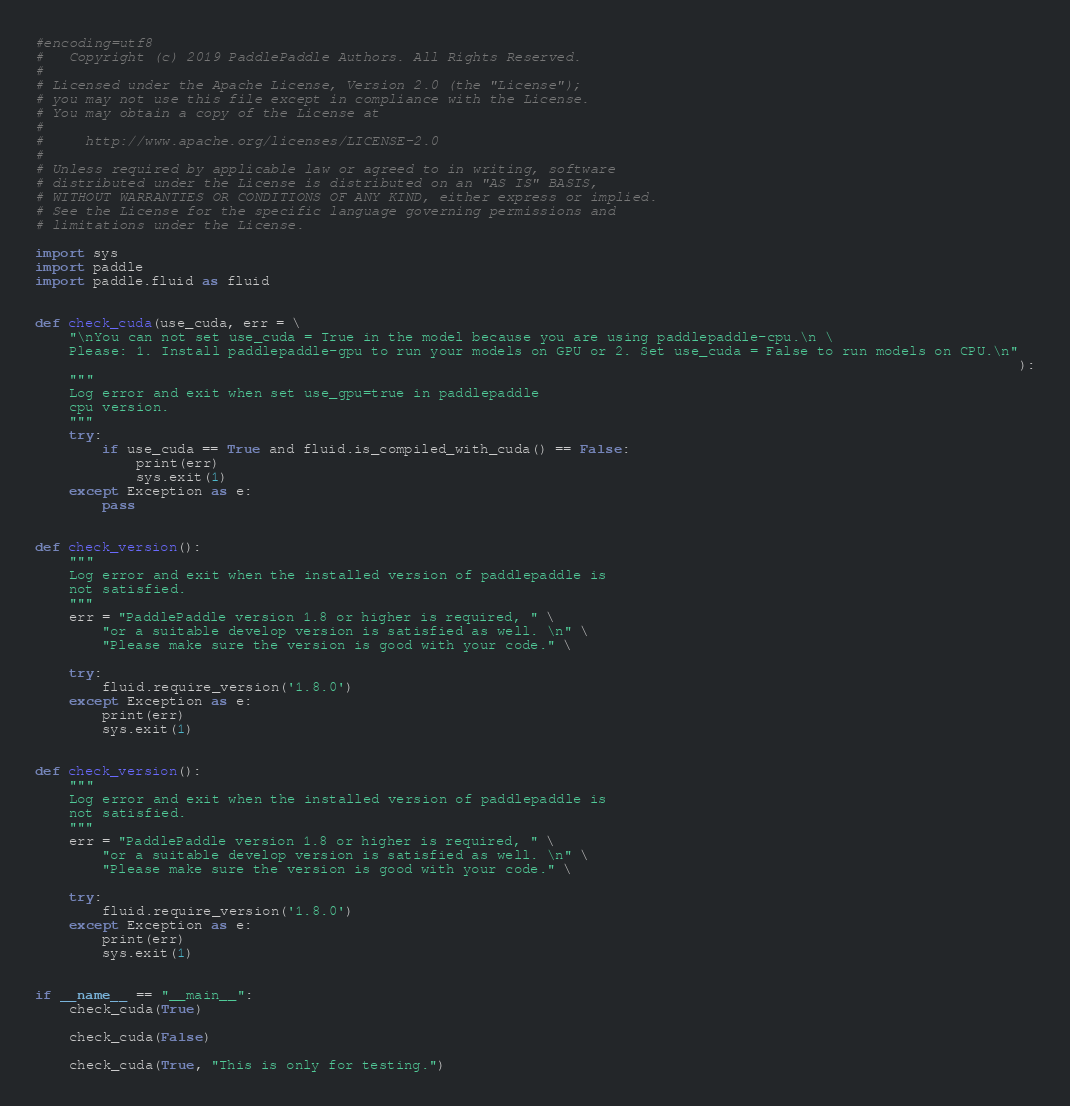<code> <loc_0><loc_0><loc_500><loc_500><_Python_>#encoding=utf8
#   Copyright (c) 2019 PaddlePaddle Authors. All Rights Reserved.
#
# Licensed under the Apache License, Version 2.0 (the "License");
# you may not use this file except in compliance with the License.
# You may obtain a copy of the License at
#
#     http://www.apache.org/licenses/LICENSE-2.0
#
# Unless required by applicable law or agreed to in writing, software
# distributed under the License is distributed on an "AS IS" BASIS,
# WITHOUT WARRANTIES OR CONDITIONS OF ANY KIND, either express or implied.
# See the License for the specific language governing permissions and
# limitations under the License.

import sys
import paddle
import paddle.fluid as fluid


def check_cuda(use_cuda, err = \
    "\nYou can not set use_cuda = True in the model because you are using paddlepaddle-cpu.\n \
    Please: 1. Install paddlepaddle-gpu to run your models on GPU or 2. Set use_cuda = False to run models on CPU.\n"
                                                                                                                     ):
    """
    Log error and exit when set use_gpu=true in paddlepaddle
    cpu version.
    """
    try:
        if use_cuda == True and fluid.is_compiled_with_cuda() == False:
            print(err)
            sys.exit(1)
    except Exception as e:
        pass


def check_version():
    """
    Log error and exit when the installed version of paddlepaddle is
    not satisfied.
    """
    err = "PaddlePaddle version 1.8 or higher is required, " \
        "or a suitable develop version is satisfied as well. \n" \
        "Please make sure the version is good with your code." \

    try:
        fluid.require_version('1.8.0')
    except Exception as e:
        print(err)
        sys.exit(1)


def check_version():
    """
    Log error and exit when the installed version of paddlepaddle is
    not satisfied.
    """
    err = "PaddlePaddle version 1.8 or higher is required, " \
        "or a suitable develop version is satisfied as well. \n" \
        "Please make sure the version is good with your code." \

    try:
        fluid.require_version('1.8.0')
    except Exception as e:
        print(err)
        sys.exit(1)


if __name__ == "__main__":
    check_cuda(True)

    check_cuda(False)

    check_cuda(True, "This is only for testing.")
</code> 